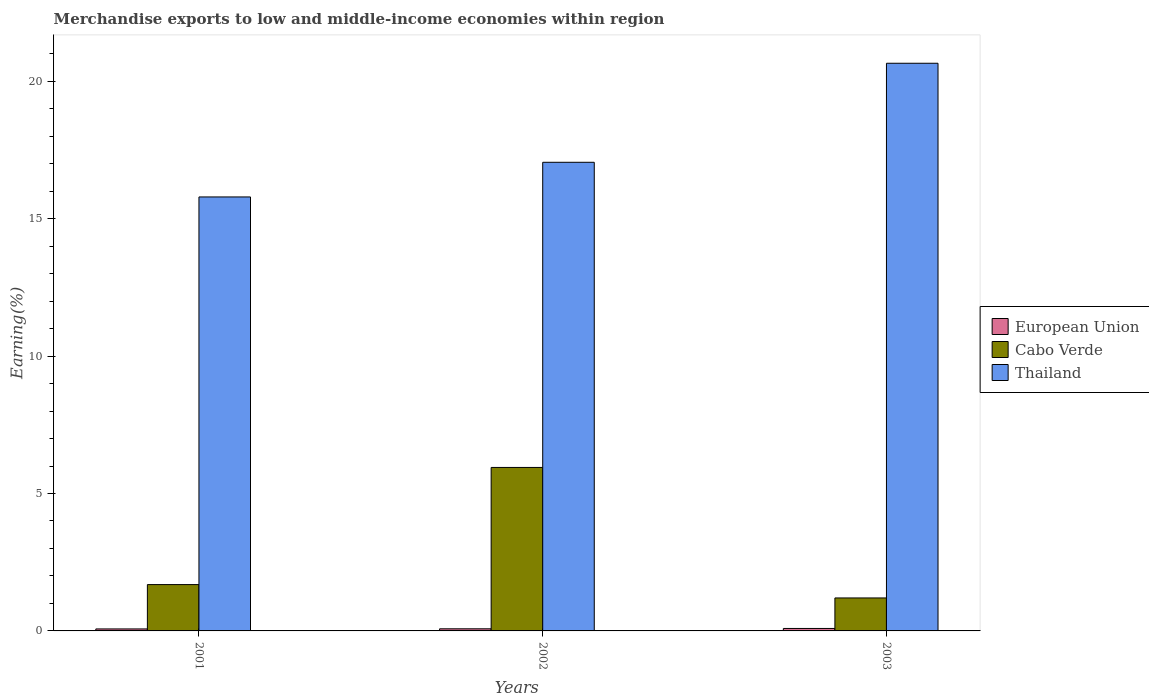How many different coloured bars are there?
Offer a very short reply. 3. How many groups of bars are there?
Give a very brief answer. 3. How many bars are there on the 3rd tick from the left?
Keep it short and to the point. 3. How many bars are there on the 1st tick from the right?
Your answer should be very brief. 3. What is the percentage of amount earned from merchandise exports in Cabo Verde in 2002?
Your answer should be compact. 5.95. Across all years, what is the maximum percentage of amount earned from merchandise exports in Cabo Verde?
Provide a short and direct response. 5.95. Across all years, what is the minimum percentage of amount earned from merchandise exports in European Union?
Keep it short and to the point. 0.07. In which year was the percentage of amount earned from merchandise exports in Cabo Verde minimum?
Your response must be concise. 2003. What is the total percentage of amount earned from merchandise exports in Thailand in the graph?
Keep it short and to the point. 53.5. What is the difference between the percentage of amount earned from merchandise exports in Thailand in 2001 and that in 2003?
Your answer should be compact. -4.86. What is the difference between the percentage of amount earned from merchandise exports in Cabo Verde in 2003 and the percentage of amount earned from merchandise exports in European Union in 2002?
Your answer should be compact. 1.12. What is the average percentage of amount earned from merchandise exports in Cabo Verde per year?
Provide a short and direct response. 2.94. In the year 2002, what is the difference between the percentage of amount earned from merchandise exports in Thailand and percentage of amount earned from merchandise exports in Cabo Verde?
Keep it short and to the point. 11.1. In how many years, is the percentage of amount earned from merchandise exports in Cabo Verde greater than 3 %?
Offer a terse response. 1. What is the ratio of the percentage of amount earned from merchandise exports in Cabo Verde in 2002 to that in 2003?
Your answer should be very brief. 4.96. What is the difference between the highest and the second highest percentage of amount earned from merchandise exports in Cabo Verde?
Offer a terse response. 4.26. What is the difference between the highest and the lowest percentage of amount earned from merchandise exports in European Union?
Ensure brevity in your answer.  0.02. Is the sum of the percentage of amount earned from merchandise exports in Thailand in 2001 and 2003 greater than the maximum percentage of amount earned from merchandise exports in European Union across all years?
Provide a succinct answer. Yes. What does the 3rd bar from the left in 2003 represents?
Ensure brevity in your answer.  Thailand. What does the 1st bar from the right in 2003 represents?
Ensure brevity in your answer.  Thailand. Are all the bars in the graph horizontal?
Offer a very short reply. No. Does the graph contain grids?
Provide a succinct answer. No. How are the legend labels stacked?
Provide a short and direct response. Vertical. What is the title of the graph?
Ensure brevity in your answer.  Merchandise exports to low and middle-income economies within region. What is the label or title of the X-axis?
Make the answer very short. Years. What is the label or title of the Y-axis?
Keep it short and to the point. Earning(%). What is the Earning(%) in European Union in 2001?
Your answer should be very brief. 0.07. What is the Earning(%) of Cabo Verde in 2001?
Keep it short and to the point. 1.69. What is the Earning(%) in Thailand in 2001?
Offer a terse response. 15.79. What is the Earning(%) of European Union in 2002?
Make the answer very short. 0.08. What is the Earning(%) of Cabo Verde in 2002?
Offer a very short reply. 5.95. What is the Earning(%) in Thailand in 2002?
Make the answer very short. 17.05. What is the Earning(%) of European Union in 2003?
Ensure brevity in your answer.  0.09. What is the Earning(%) in Cabo Verde in 2003?
Give a very brief answer. 1.2. What is the Earning(%) of Thailand in 2003?
Offer a very short reply. 20.66. Across all years, what is the maximum Earning(%) of European Union?
Provide a succinct answer. 0.09. Across all years, what is the maximum Earning(%) of Cabo Verde?
Offer a terse response. 5.95. Across all years, what is the maximum Earning(%) of Thailand?
Give a very brief answer. 20.66. Across all years, what is the minimum Earning(%) in European Union?
Your response must be concise. 0.07. Across all years, what is the minimum Earning(%) in Cabo Verde?
Offer a very short reply. 1.2. Across all years, what is the minimum Earning(%) in Thailand?
Provide a succinct answer. 15.79. What is the total Earning(%) in European Union in the graph?
Provide a succinct answer. 0.24. What is the total Earning(%) in Cabo Verde in the graph?
Give a very brief answer. 8.83. What is the total Earning(%) in Thailand in the graph?
Ensure brevity in your answer.  53.5. What is the difference between the Earning(%) of European Union in 2001 and that in 2002?
Your answer should be very brief. -0. What is the difference between the Earning(%) in Cabo Verde in 2001 and that in 2002?
Offer a terse response. -4.26. What is the difference between the Earning(%) of Thailand in 2001 and that in 2002?
Make the answer very short. -1.26. What is the difference between the Earning(%) in European Union in 2001 and that in 2003?
Make the answer very short. -0.02. What is the difference between the Earning(%) in Cabo Verde in 2001 and that in 2003?
Make the answer very short. 0.49. What is the difference between the Earning(%) in Thailand in 2001 and that in 2003?
Your answer should be compact. -4.86. What is the difference between the Earning(%) in European Union in 2002 and that in 2003?
Provide a succinct answer. -0.01. What is the difference between the Earning(%) of Cabo Verde in 2002 and that in 2003?
Your answer should be very brief. 4.75. What is the difference between the Earning(%) in Thailand in 2002 and that in 2003?
Your answer should be very brief. -3.6. What is the difference between the Earning(%) of European Union in 2001 and the Earning(%) of Cabo Verde in 2002?
Your response must be concise. -5.88. What is the difference between the Earning(%) in European Union in 2001 and the Earning(%) in Thailand in 2002?
Offer a very short reply. -16.98. What is the difference between the Earning(%) in Cabo Verde in 2001 and the Earning(%) in Thailand in 2002?
Offer a terse response. -15.37. What is the difference between the Earning(%) of European Union in 2001 and the Earning(%) of Cabo Verde in 2003?
Keep it short and to the point. -1.13. What is the difference between the Earning(%) in European Union in 2001 and the Earning(%) in Thailand in 2003?
Offer a terse response. -20.58. What is the difference between the Earning(%) of Cabo Verde in 2001 and the Earning(%) of Thailand in 2003?
Make the answer very short. -18.97. What is the difference between the Earning(%) in European Union in 2002 and the Earning(%) in Cabo Verde in 2003?
Ensure brevity in your answer.  -1.12. What is the difference between the Earning(%) of European Union in 2002 and the Earning(%) of Thailand in 2003?
Offer a very short reply. -20.58. What is the difference between the Earning(%) in Cabo Verde in 2002 and the Earning(%) in Thailand in 2003?
Your response must be concise. -14.71. What is the average Earning(%) of European Union per year?
Give a very brief answer. 0.08. What is the average Earning(%) in Cabo Verde per year?
Give a very brief answer. 2.94. What is the average Earning(%) in Thailand per year?
Ensure brevity in your answer.  17.83. In the year 2001, what is the difference between the Earning(%) of European Union and Earning(%) of Cabo Verde?
Offer a very short reply. -1.61. In the year 2001, what is the difference between the Earning(%) of European Union and Earning(%) of Thailand?
Make the answer very short. -15.72. In the year 2001, what is the difference between the Earning(%) in Cabo Verde and Earning(%) in Thailand?
Your response must be concise. -14.1. In the year 2002, what is the difference between the Earning(%) in European Union and Earning(%) in Cabo Verde?
Give a very brief answer. -5.87. In the year 2002, what is the difference between the Earning(%) in European Union and Earning(%) in Thailand?
Offer a terse response. -16.97. In the year 2002, what is the difference between the Earning(%) of Cabo Verde and Earning(%) of Thailand?
Your answer should be very brief. -11.1. In the year 2003, what is the difference between the Earning(%) in European Union and Earning(%) in Cabo Verde?
Offer a very short reply. -1.11. In the year 2003, what is the difference between the Earning(%) of European Union and Earning(%) of Thailand?
Provide a short and direct response. -20.57. In the year 2003, what is the difference between the Earning(%) in Cabo Verde and Earning(%) in Thailand?
Provide a short and direct response. -19.46. What is the ratio of the Earning(%) of European Union in 2001 to that in 2002?
Ensure brevity in your answer.  0.94. What is the ratio of the Earning(%) of Cabo Verde in 2001 to that in 2002?
Your response must be concise. 0.28. What is the ratio of the Earning(%) in Thailand in 2001 to that in 2002?
Provide a short and direct response. 0.93. What is the ratio of the Earning(%) in European Union in 2001 to that in 2003?
Offer a very short reply. 0.81. What is the ratio of the Earning(%) in Cabo Verde in 2001 to that in 2003?
Give a very brief answer. 1.41. What is the ratio of the Earning(%) in Thailand in 2001 to that in 2003?
Give a very brief answer. 0.76. What is the ratio of the Earning(%) in European Union in 2002 to that in 2003?
Offer a very short reply. 0.86. What is the ratio of the Earning(%) in Cabo Verde in 2002 to that in 2003?
Your response must be concise. 4.96. What is the ratio of the Earning(%) in Thailand in 2002 to that in 2003?
Provide a short and direct response. 0.83. What is the difference between the highest and the second highest Earning(%) in European Union?
Give a very brief answer. 0.01. What is the difference between the highest and the second highest Earning(%) of Cabo Verde?
Your answer should be compact. 4.26. What is the difference between the highest and the second highest Earning(%) in Thailand?
Your answer should be very brief. 3.6. What is the difference between the highest and the lowest Earning(%) in European Union?
Make the answer very short. 0.02. What is the difference between the highest and the lowest Earning(%) in Cabo Verde?
Your answer should be compact. 4.75. What is the difference between the highest and the lowest Earning(%) in Thailand?
Ensure brevity in your answer.  4.86. 